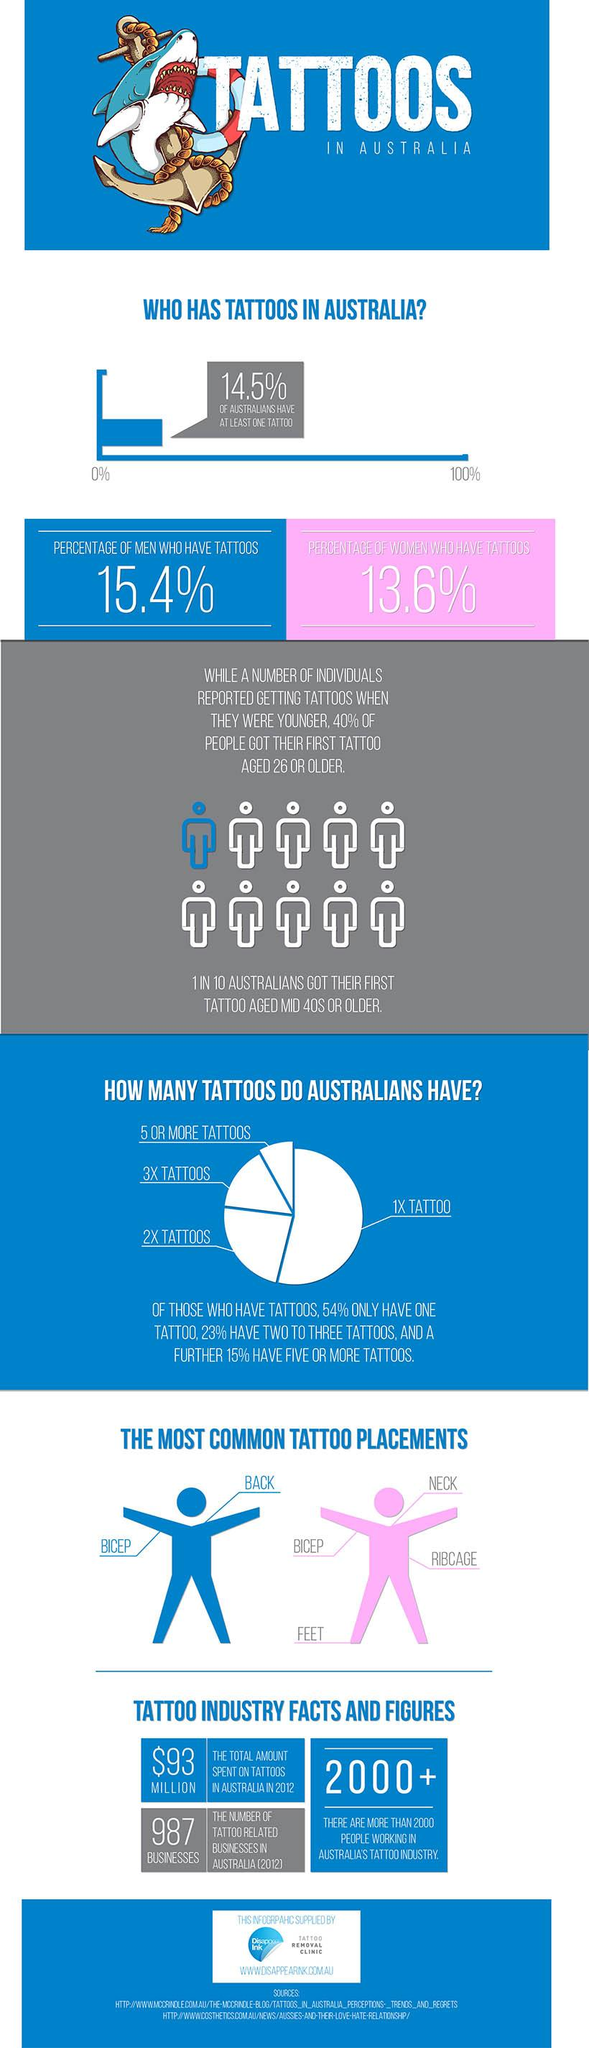Mention a couple of crucial points in this snapshot. The given infographic shows 4 tattoo placements for women. According to the given infographic, approximately 85.5% of Australians do not have even a single tattoo. The most common tattoo placements among Australian men are the bicep and the back. 